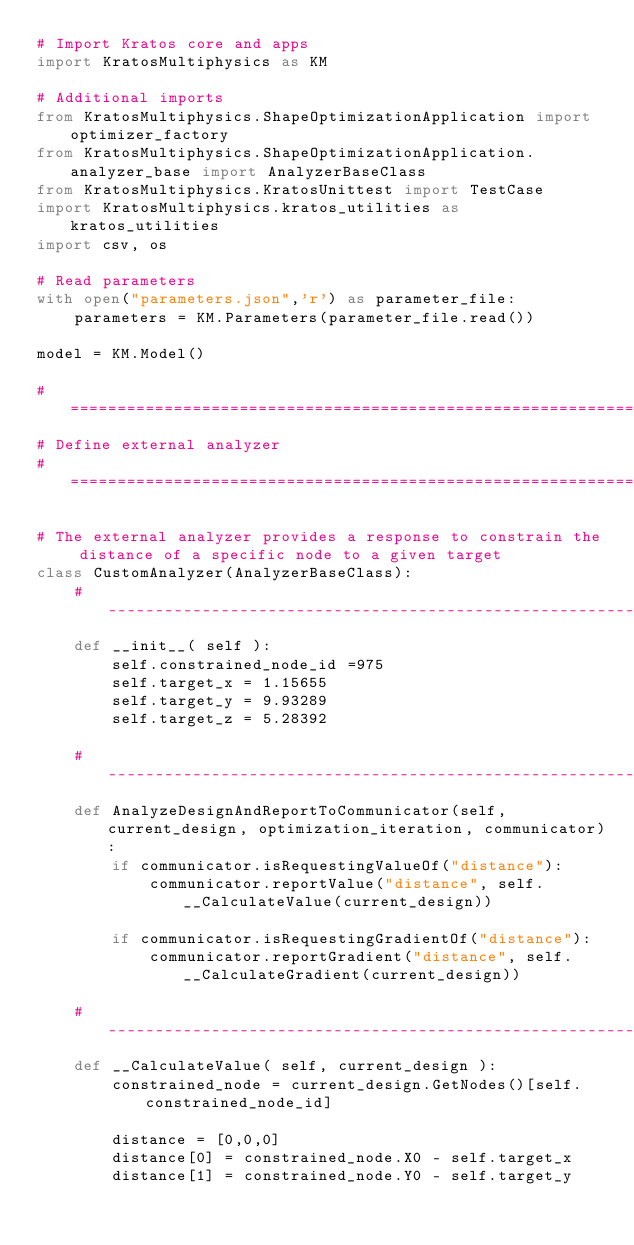Convert code to text. <code><loc_0><loc_0><loc_500><loc_500><_Python_># Import Kratos core and apps
import KratosMultiphysics as KM

# Additional imports
from KratosMultiphysics.ShapeOptimizationApplication import optimizer_factory
from KratosMultiphysics.ShapeOptimizationApplication.analyzer_base import AnalyzerBaseClass
from KratosMultiphysics.KratosUnittest import TestCase
import KratosMultiphysics.kratos_utilities as kratos_utilities
import csv, os

# Read parameters
with open("parameters.json",'r') as parameter_file:
    parameters = KM.Parameters(parameter_file.read())

model = KM.Model()

# =======================================================================================================
# Define external analyzer
# =======================================================================================================

# The external analyzer provides a response to constrain the distance of a specific node to a given target
class CustomAnalyzer(AnalyzerBaseClass):
    # --------------------------------------------------------------------------------------------------
    def __init__( self ):
        self.constrained_node_id =975
        self.target_x = 1.15655
        self.target_y = 9.93289
        self.target_z = 5.28392

    # --------------------------------------------------------------------------------------------------
    def AnalyzeDesignAndReportToCommunicator(self, current_design, optimization_iteration, communicator):
        if communicator.isRequestingValueOf("distance"):
            communicator.reportValue("distance", self.__CalculateValue(current_design))

        if communicator.isRequestingGradientOf("distance"):
            communicator.reportGradient("distance", self.__CalculateGradient(current_design))

    # --------------------------------------------------------------------------
    def __CalculateValue( self, current_design ):
        constrained_node = current_design.GetNodes()[self.constrained_node_id]

        distance = [0,0,0]
        distance[0] = constrained_node.X0 - self.target_x
        distance[1] = constrained_node.Y0 - self.target_y</code> 